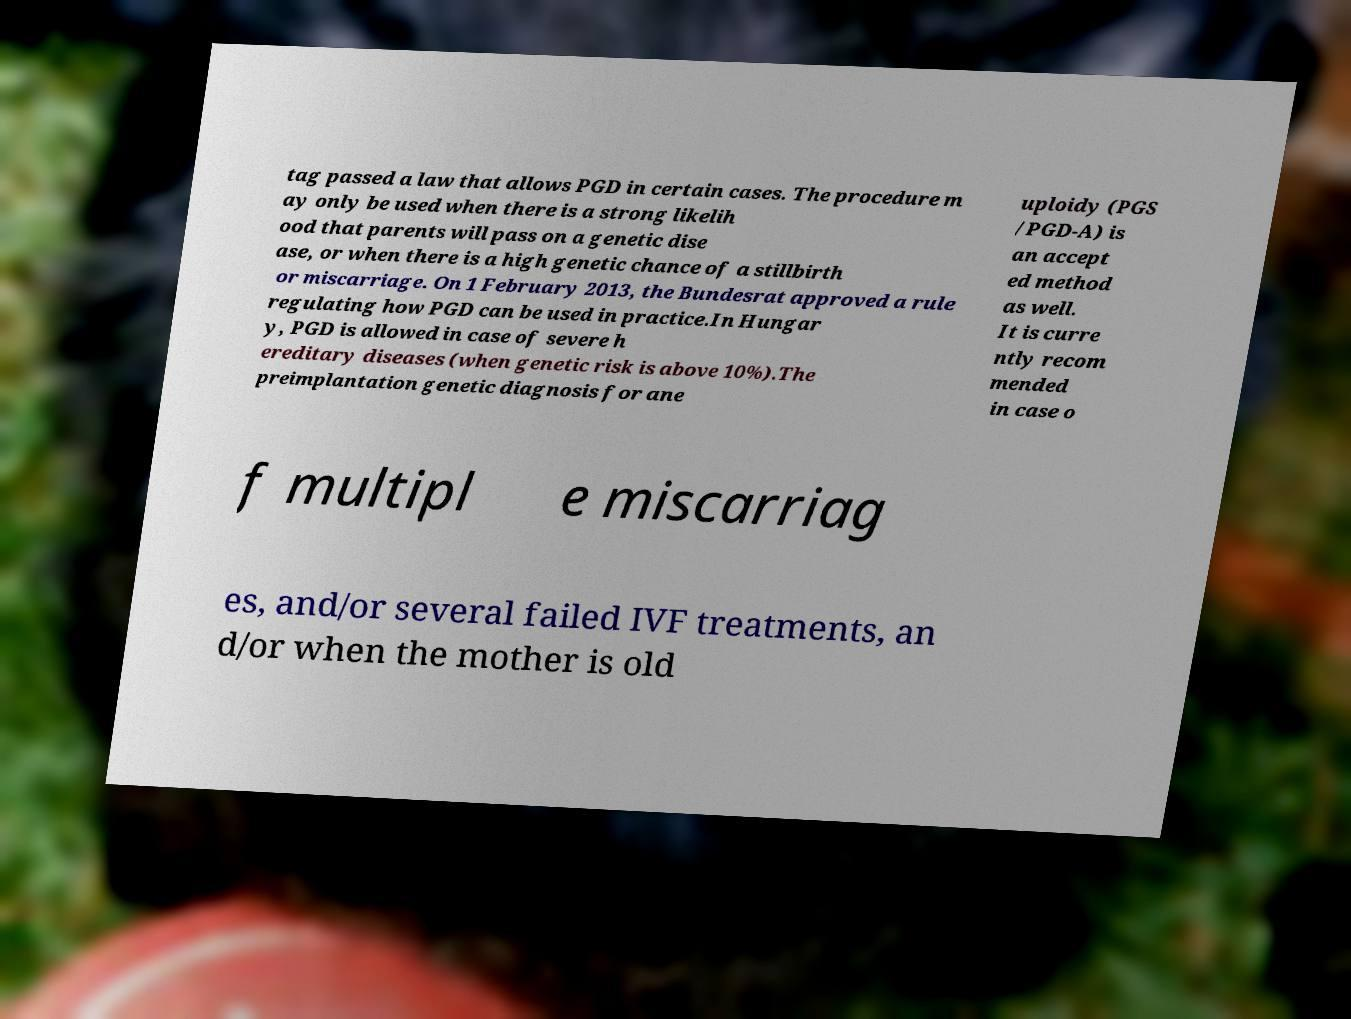Please read and relay the text visible in this image. What does it say? tag passed a law that allows PGD in certain cases. The procedure m ay only be used when there is a strong likelih ood that parents will pass on a genetic dise ase, or when there is a high genetic chance of a stillbirth or miscarriage. On 1 February 2013, the Bundesrat approved a rule regulating how PGD can be used in practice.In Hungar y, PGD is allowed in case of severe h ereditary diseases (when genetic risk is above 10%).The preimplantation genetic diagnosis for ane uploidy (PGS /PGD-A) is an accept ed method as well. It is curre ntly recom mended in case o f multipl e miscarriag es, and/or several failed IVF treatments, an d/or when the mother is old 